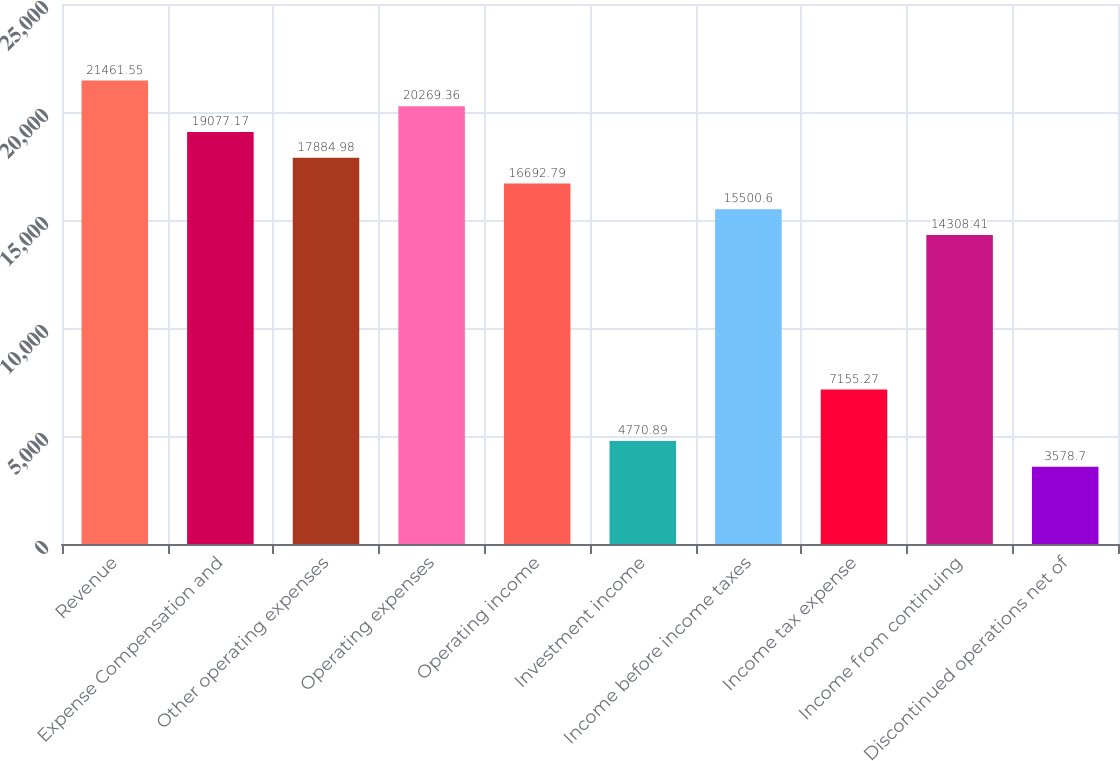Convert chart to OTSL. <chart><loc_0><loc_0><loc_500><loc_500><bar_chart><fcel>Revenue<fcel>Expense Compensation and<fcel>Other operating expenses<fcel>Operating expenses<fcel>Operating income<fcel>Investment income<fcel>Income before income taxes<fcel>Income tax expense<fcel>Income from continuing<fcel>Discontinued operations net of<nl><fcel>21461.5<fcel>19077.2<fcel>17885<fcel>20269.4<fcel>16692.8<fcel>4770.89<fcel>15500.6<fcel>7155.27<fcel>14308.4<fcel>3578.7<nl></chart> 